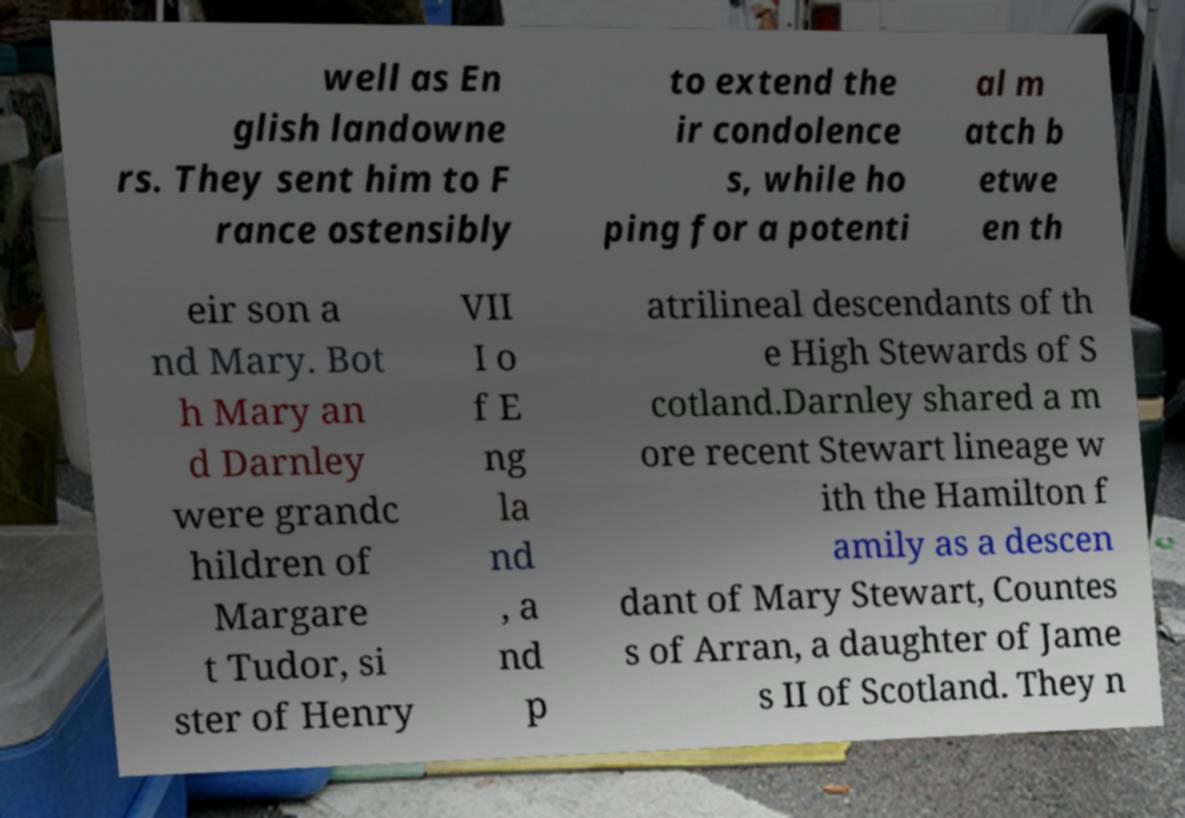Please identify and transcribe the text found in this image. well as En glish landowne rs. They sent him to F rance ostensibly to extend the ir condolence s, while ho ping for a potenti al m atch b etwe en th eir son a nd Mary. Bot h Mary an d Darnley were grandc hildren of Margare t Tudor, si ster of Henry VII I o f E ng la nd , a nd p atrilineal descendants of th e High Stewards of S cotland.Darnley shared a m ore recent Stewart lineage w ith the Hamilton f amily as a descen dant of Mary Stewart, Countes s of Arran, a daughter of Jame s II of Scotland. They n 